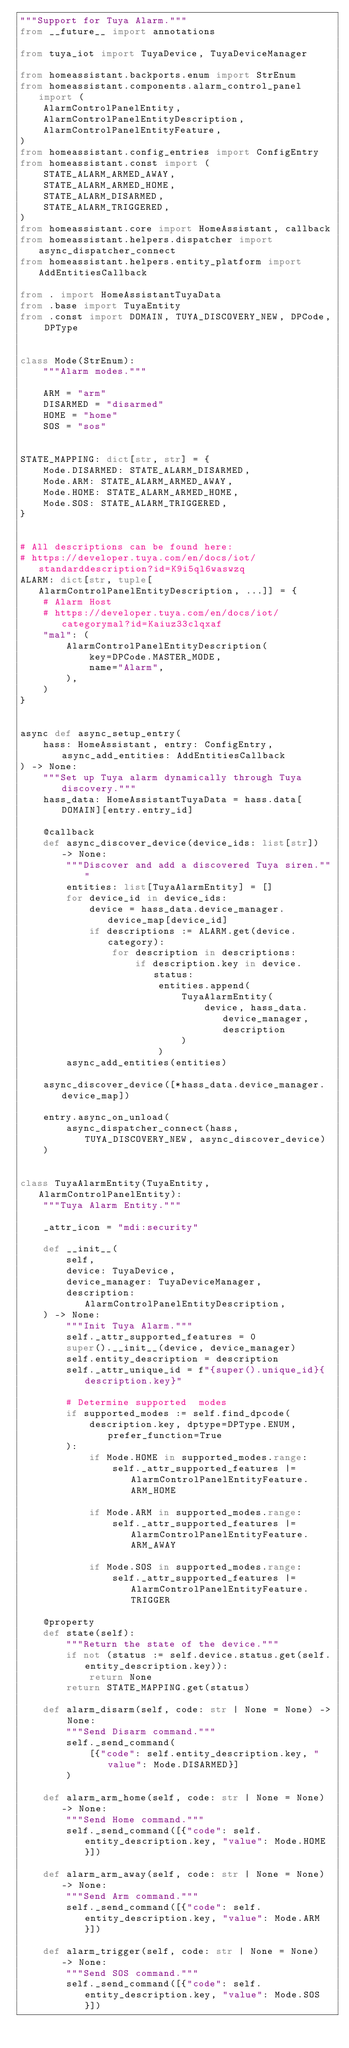Convert code to text. <code><loc_0><loc_0><loc_500><loc_500><_Python_>"""Support for Tuya Alarm."""
from __future__ import annotations

from tuya_iot import TuyaDevice, TuyaDeviceManager

from homeassistant.backports.enum import StrEnum
from homeassistant.components.alarm_control_panel import (
    AlarmControlPanelEntity,
    AlarmControlPanelEntityDescription,
    AlarmControlPanelEntityFeature,
)
from homeassistant.config_entries import ConfigEntry
from homeassistant.const import (
    STATE_ALARM_ARMED_AWAY,
    STATE_ALARM_ARMED_HOME,
    STATE_ALARM_DISARMED,
    STATE_ALARM_TRIGGERED,
)
from homeassistant.core import HomeAssistant, callback
from homeassistant.helpers.dispatcher import async_dispatcher_connect
from homeassistant.helpers.entity_platform import AddEntitiesCallback

from . import HomeAssistantTuyaData
from .base import TuyaEntity
from .const import DOMAIN, TUYA_DISCOVERY_NEW, DPCode, DPType


class Mode(StrEnum):
    """Alarm modes."""

    ARM = "arm"
    DISARMED = "disarmed"
    HOME = "home"
    SOS = "sos"


STATE_MAPPING: dict[str, str] = {
    Mode.DISARMED: STATE_ALARM_DISARMED,
    Mode.ARM: STATE_ALARM_ARMED_AWAY,
    Mode.HOME: STATE_ALARM_ARMED_HOME,
    Mode.SOS: STATE_ALARM_TRIGGERED,
}


# All descriptions can be found here:
# https://developer.tuya.com/en/docs/iot/standarddescription?id=K9i5ql6waswzq
ALARM: dict[str, tuple[AlarmControlPanelEntityDescription, ...]] = {
    # Alarm Host
    # https://developer.tuya.com/en/docs/iot/categorymal?id=Kaiuz33clqxaf
    "mal": (
        AlarmControlPanelEntityDescription(
            key=DPCode.MASTER_MODE,
            name="Alarm",
        ),
    )
}


async def async_setup_entry(
    hass: HomeAssistant, entry: ConfigEntry, async_add_entities: AddEntitiesCallback
) -> None:
    """Set up Tuya alarm dynamically through Tuya discovery."""
    hass_data: HomeAssistantTuyaData = hass.data[DOMAIN][entry.entry_id]

    @callback
    def async_discover_device(device_ids: list[str]) -> None:
        """Discover and add a discovered Tuya siren."""
        entities: list[TuyaAlarmEntity] = []
        for device_id in device_ids:
            device = hass_data.device_manager.device_map[device_id]
            if descriptions := ALARM.get(device.category):
                for description in descriptions:
                    if description.key in device.status:
                        entities.append(
                            TuyaAlarmEntity(
                                device, hass_data.device_manager, description
                            )
                        )
        async_add_entities(entities)

    async_discover_device([*hass_data.device_manager.device_map])

    entry.async_on_unload(
        async_dispatcher_connect(hass, TUYA_DISCOVERY_NEW, async_discover_device)
    )


class TuyaAlarmEntity(TuyaEntity, AlarmControlPanelEntity):
    """Tuya Alarm Entity."""

    _attr_icon = "mdi:security"

    def __init__(
        self,
        device: TuyaDevice,
        device_manager: TuyaDeviceManager,
        description: AlarmControlPanelEntityDescription,
    ) -> None:
        """Init Tuya Alarm."""
        self._attr_supported_features = 0
        super().__init__(device, device_manager)
        self.entity_description = description
        self._attr_unique_id = f"{super().unique_id}{description.key}"

        # Determine supported  modes
        if supported_modes := self.find_dpcode(
            description.key, dptype=DPType.ENUM, prefer_function=True
        ):
            if Mode.HOME in supported_modes.range:
                self._attr_supported_features |= AlarmControlPanelEntityFeature.ARM_HOME

            if Mode.ARM in supported_modes.range:
                self._attr_supported_features |= AlarmControlPanelEntityFeature.ARM_AWAY

            if Mode.SOS in supported_modes.range:
                self._attr_supported_features |= AlarmControlPanelEntityFeature.TRIGGER

    @property
    def state(self):
        """Return the state of the device."""
        if not (status := self.device.status.get(self.entity_description.key)):
            return None
        return STATE_MAPPING.get(status)

    def alarm_disarm(self, code: str | None = None) -> None:
        """Send Disarm command."""
        self._send_command(
            [{"code": self.entity_description.key, "value": Mode.DISARMED}]
        )

    def alarm_arm_home(self, code: str | None = None) -> None:
        """Send Home command."""
        self._send_command([{"code": self.entity_description.key, "value": Mode.HOME}])

    def alarm_arm_away(self, code: str | None = None) -> None:
        """Send Arm command."""
        self._send_command([{"code": self.entity_description.key, "value": Mode.ARM}])

    def alarm_trigger(self, code: str | None = None) -> None:
        """Send SOS command."""
        self._send_command([{"code": self.entity_description.key, "value": Mode.SOS}])
</code> 